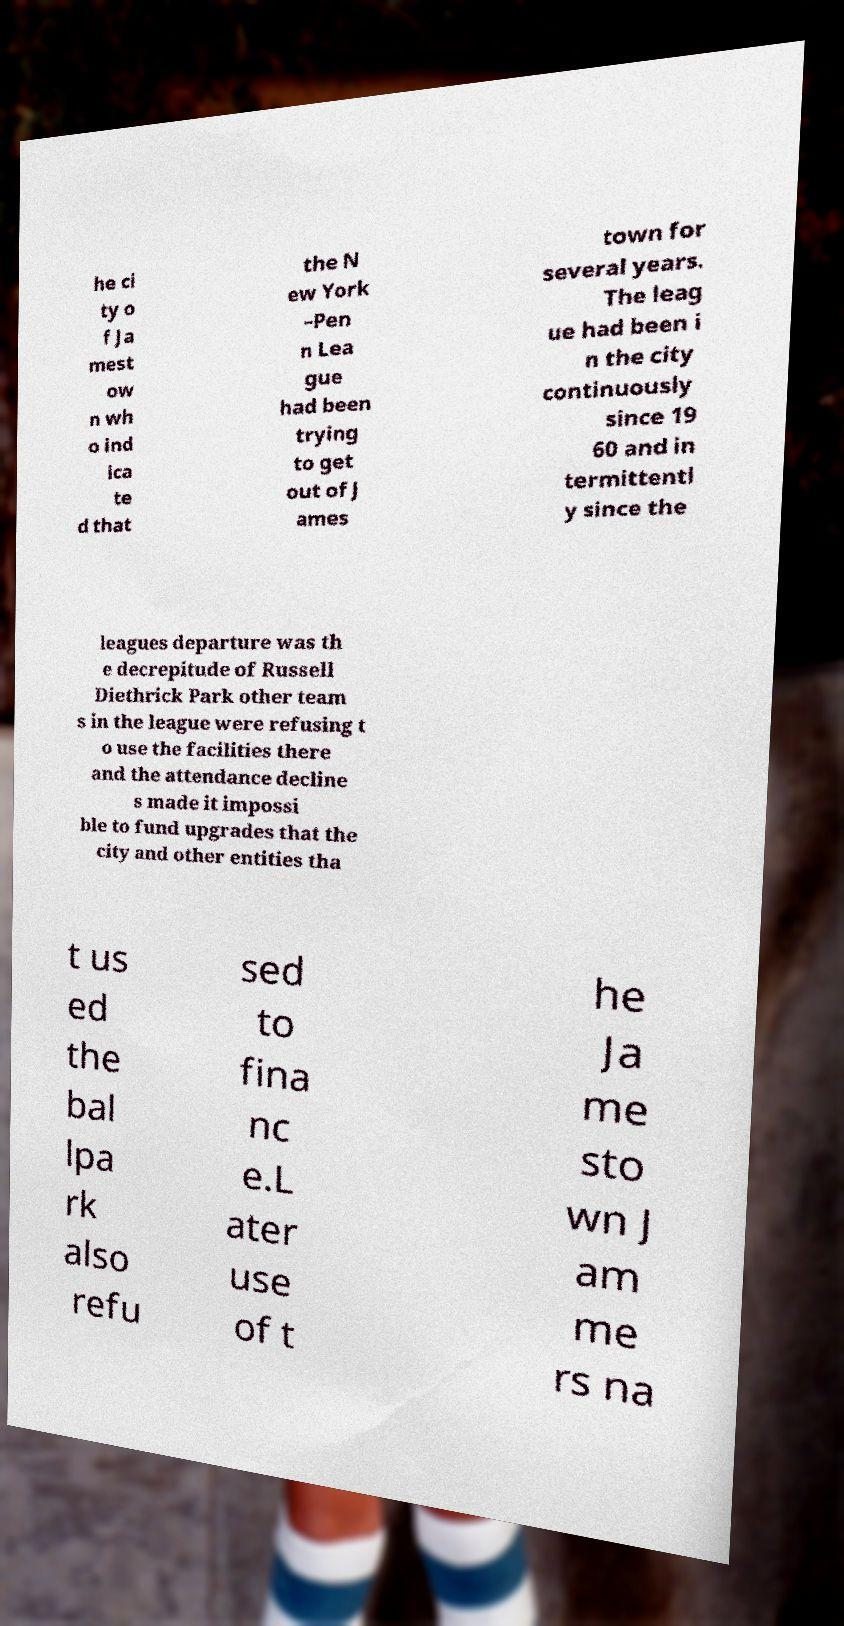Can you accurately transcribe the text from the provided image for me? he ci ty o f Ja mest ow n wh o ind ica te d that the N ew York –Pen n Lea gue had been trying to get out of J ames town for several years. The leag ue had been i n the city continuously since 19 60 and in termittentl y since the leagues departure was th e decrepitude of Russell Diethrick Park other team s in the league were refusing t o use the facilities there and the attendance decline s made it impossi ble to fund upgrades that the city and other entities tha t us ed the bal lpa rk also refu sed to fina nc e.L ater use of t he Ja me sto wn J am me rs na 